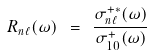<formula> <loc_0><loc_0><loc_500><loc_500>R _ { n \ell } ( \omega ) \ = \ \frac { \sigma ^ { + * } _ { n \ell } ( \omega ) } { \sigma ^ { + } _ { 1 0 } ( \omega ) }</formula> 